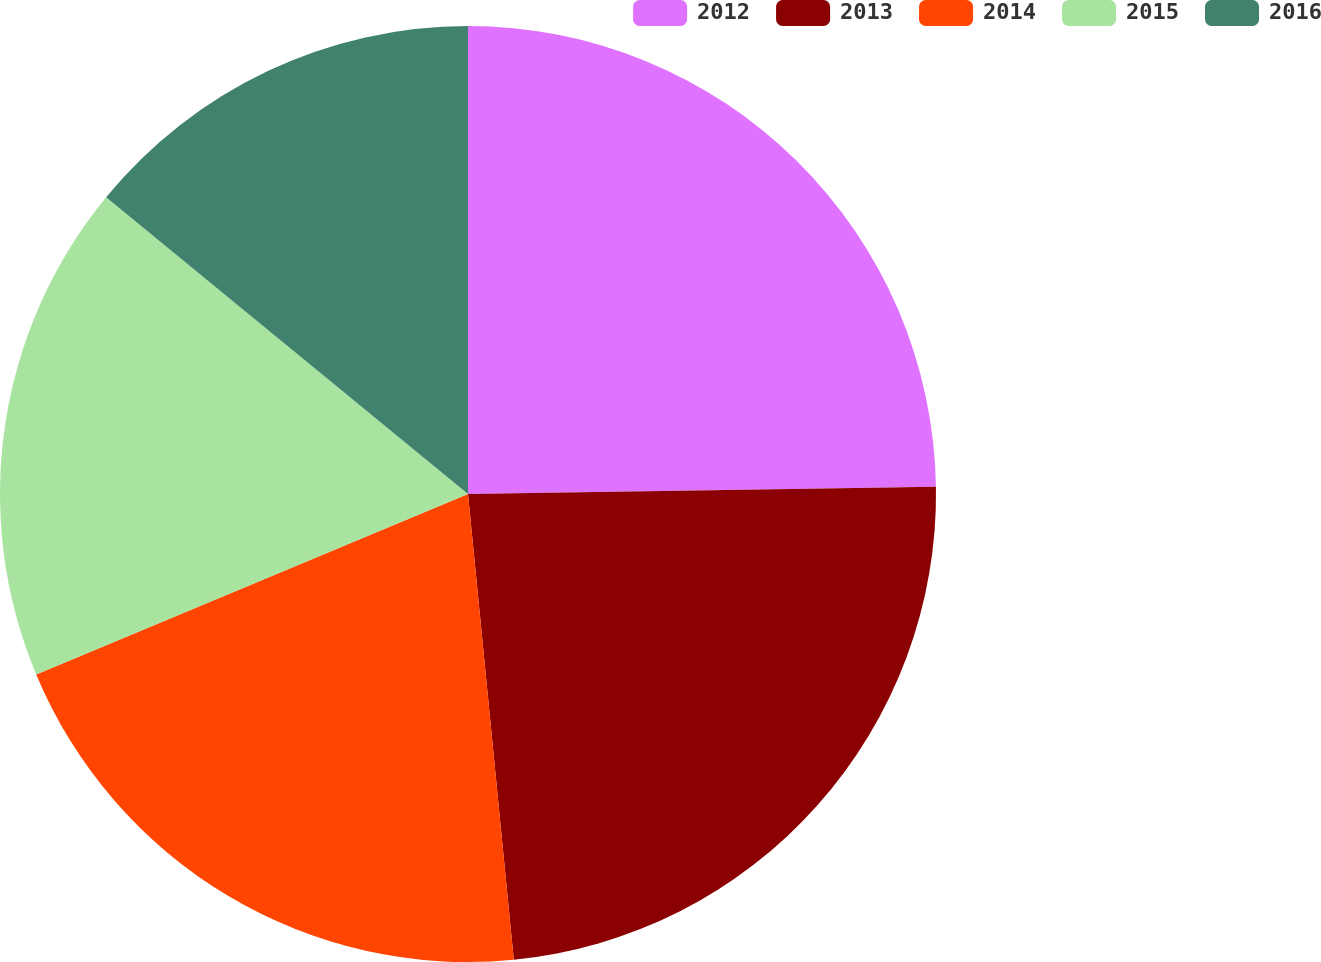<chart> <loc_0><loc_0><loc_500><loc_500><pie_chart><fcel>2012<fcel>2013<fcel>2014<fcel>2015<fcel>2016<nl><fcel>24.75%<fcel>23.69%<fcel>20.26%<fcel>17.23%<fcel>14.07%<nl></chart> 